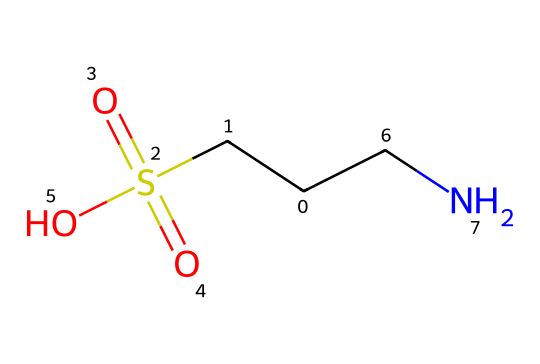What is the molecular formula of taurine? The SMILES representation indicates the atoms present in taurine: one carbon atom from the methyl group, one carbon atom in the main chain, one nitrogen atom (N), and one sulfur atom (S), along with the sulfate (SO3) group. Counting these gives the empirical formula C2H7NO3S.
Answer: C2H7NO3S How many carbon atoms are in taurine? The SMILES shows two distinctive carbon atoms in the structure, one within the sulfamic group and the other as part of the main chain. Counting these carbon atoms gives a total of two.
Answer: 2 What type of functional group is present in taurine? Analyzing the SMILES, we can identify a sulfonic acid functional group (due to the presence of S(=O)(=O) in the structure). This signifies that taurine has the sulfonic acid characteristic.
Answer: sulfonic acid How many oxygen atoms does taurine contain? The SMILES representation shows three oxygen atoms connected to the sulfur atom in the sulfonic group and one oxygen in the hydroxyl (-OH) group, thus constituting a total of four oxygen atoms in the structure.
Answer: 4 What is the primary element that defines taurine as an amino acid derivative? The presence of the nitrogen atom (N) in the structure is essential, which confirms taurine's classification as an amino acid derivative, specifically being a sulfonic amino acid.
Answer: nitrogen Which part of taurine contributes to its solubility in water? The hydroxyl group (-OH) and the sulfonic acid group (S(=O)(=O)OH) in the chemical structure enable strong hydrogen bonding with water molecules, thus enhancing its solubility in water.
Answer: hydroxyl group and sulfonic acid group Is taurine considered a basic or acidic compound? Evaluating the structural components, taurine has a sulfonic acid functional group which has acidic properties, making taurine an acidic compound overall rather than basic.
Answer: acidic compound 